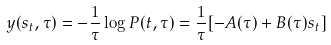Convert formula to latex. <formula><loc_0><loc_0><loc_500><loc_500>y ( s _ { t } , \tau ) = - \frac { 1 } { \tau } \log P ( t , \tau ) = \frac { 1 } { \tau } [ - A ( \tau ) + B ( \tau ) s _ { t } ]</formula> 